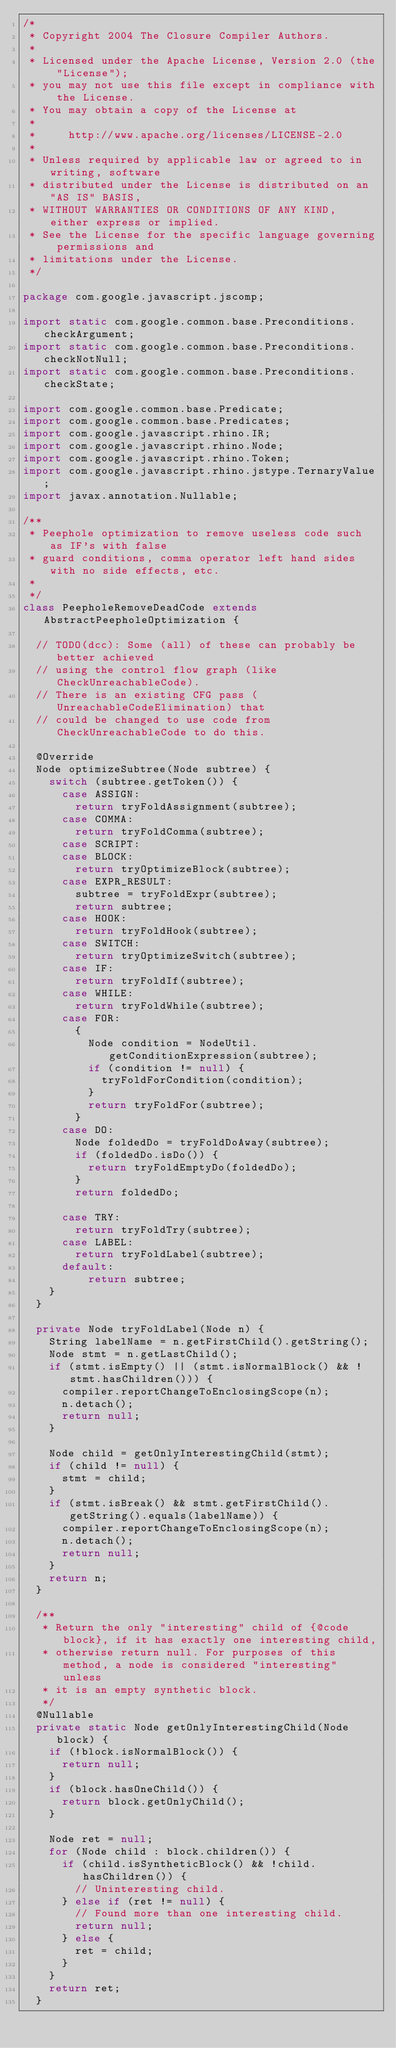<code> <loc_0><loc_0><loc_500><loc_500><_Java_>/*
 * Copyright 2004 The Closure Compiler Authors.
 *
 * Licensed under the Apache License, Version 2.0 (the "License");
 * you may not use this file except in compliance with the License.
 * You may obtain a copy of the License at
 *
 *     http://www.apache.org/licenses/LICENSE-2.0
 *
 * Unless required by applicable law or agreed to in writing, software
 * distributed under the License is distributed on an "AS IS" BASIS,
 * WITHOUT WARRANTIES OR CONDITIONS OF ANY KIND, either express or implied.
 * See the License for the specific language governing permissions and
 * limitations under the License.
 */

package com.google.javascript.jscomp;

import static com.google.common.base.Preconditions.checkArgument;
import static com.google.common.base.Preconditions.checkNotNull;
import static com.google.common.base.Preconditions.checkState;

import com.google.common.base.Predicate;
import com.google.common.base.Predicates;
import com.google.javascript.rhino.IR;
import com.google.javascript.rhino.Node;
import com.google.javascript.rhino.Token;
import com.google.javascript.rhino.jstype.TernaryValue;
import javax.annotation.Nullable;

/**
 * Peephole optimization to remove useless code such as IF's with false
 * guard conditions, comma operator left hand sides with no side effects, etc.
 *
 */
class PeepholeRemoveDeadCode extends AbstractPeepholeOptimization {

  // TODO(dcc): Some (all) of these can probably be better achieved
  // using the control flow graph (like CheckUnreachableCode).
  // There is an existing CFG pass (UnreachableCodeElimination) that
  // could be changed to use code from CheckUnreachableCode to do this.

  @Override
  Node optimizeSubtree(Node subtree) {
    switch (subtree.getToken()) {
      case ASSIGN:
        return tryFoldAssignment(subtree);
      case COMMA:
        return tryFoldComma(subtree);
      case SCRIPT:
      case BLOCK:
        return tryOptimizeBlock(subtree);
      case EXPR_RESULT:
        subtree = tryFoldExpr(subtree);
        return subtree;
      case HOOK:
        return tryFoldHook(subtree);
      case SWITCH:
        return tryOptimizeSwitch(subtree);
      case IF:
        return tryFoldIf(subtree);
      case WHILE:
        return tryFoldWhile(subtree);
      case FOR:
        {
          Node condition = NodeUtil.getConditionExpression(subtree);
          if (condition != null) {
            tryFoldForCondition(condition);
          }
          return tryFoldFor(subtree);
        }
      case DO:
        Node foldedDo = tryFoldDoAway(subtree);
        if (foldedDo.isDo()) {
          return tryFoldEmptyDo(foldedDo);
        }
        return foldedDo;

      case TRY:
        return tryFoldTry(subtree);
      case LABEL:
        return tryFoldLabel(subtree);
      default:
          return subtree;
    }
  }

  private Node tryFoldLabel(Node n) {
    String labelName = n.getFirstChild().getString();
    Node stmt = n.getLastChild();
    if (stmt.isEmpty() || (stmt.isNormalBlock() && !stmt.hasChildren())) {
      compiler.reportChangeToEnclosingScope(n);
      n.detach();
      return null;
    }

    Node child = getOnlyInterestingChild(stmt);
    if (child != null) {
      stmt = child;
    }
    if (stmt.isBreak() && stmt.getFirstChild().getString().equals(labelName)) {
      compiler.reportChangeToEnclosingScope(n);
      n.detach();
      return null;
    }
    return n;
  }

  /**
   * Return the only "interesting" child of {@code block}, if it has exactly one interesting child,
   * otherwise return null. For purposes of this method, a node is considered "interesting" unless
   * it is an empty synthetic block.
   */
  @Nullable
  private static Node getOnlyInterestingChild(Node block) {
    if (!block.isNormalBlock()) {
      return null;
    }
    if (block.hasOneChild()) {
      return block.getOnlyChild();
    }

    Node ret = null;
    for (Node child : block.children()) {
      if (child.isSyntheticBlock() && !child.hasChildren()) {
        // Uninteresting child.
      } else if (ret != null) {
        // Found more than one interesting child.
        return null;
      } else {
        ret = child;
      }
    }
    return ret;
  }
</code> 